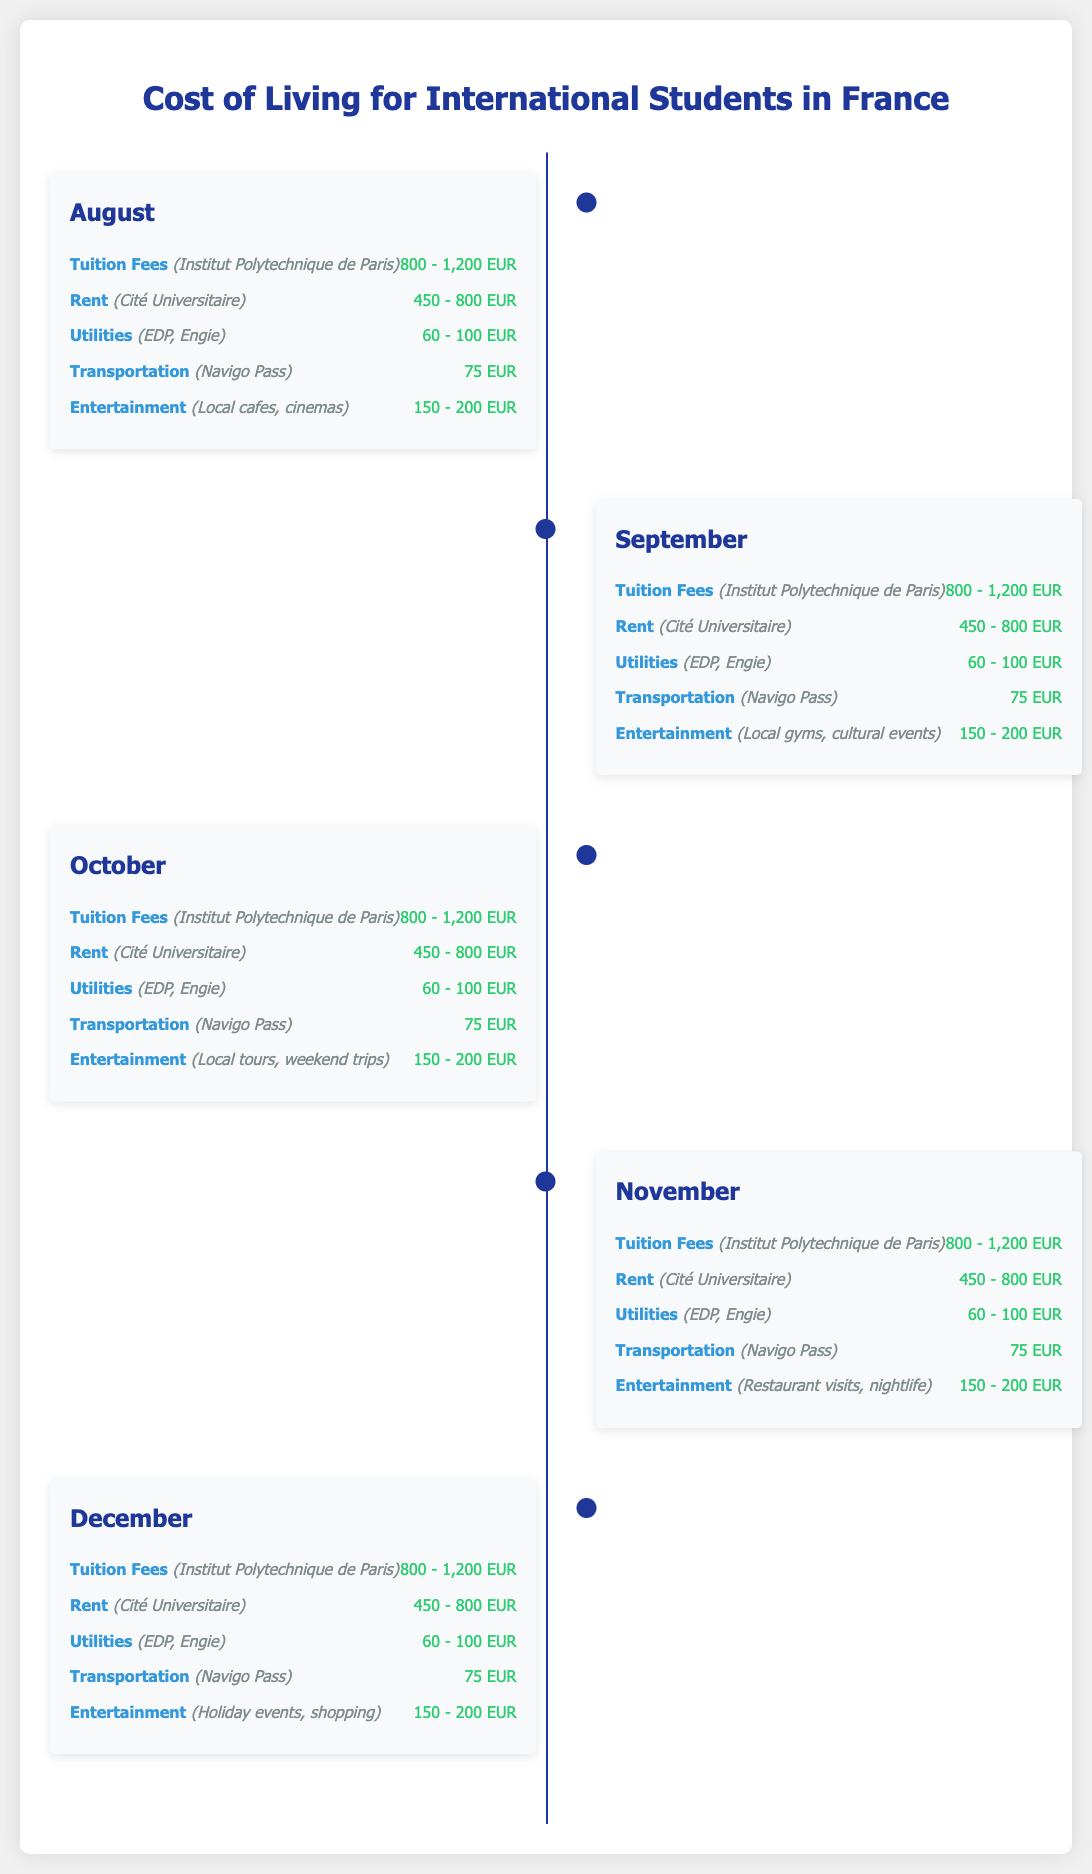What is the monthly rent range for August? The monthly rent range for August is specified in the "Rent" section under the month, which is 450 - 800 EUR.
Answer: 450 - 800 EUR How much is the transportation cost for September? The transportation cost for September is detailed in the "Transportation" section, which is 75 EUR.
Answer: 75 EUR What is the range of tuition fees for International Students? The tuition fees are listed as 800 - 1,200 EUR for each month from August to December.
Answer: 800 - 1,200 EUR Which month has entertainment costs for holiday events? The entertainment costs for holiday events are detailed for the month of December.
Answer: December What is the average utility bill range across all months? The average utility bill range is consistent at 60 - 100 EUR for all months, as stated in each monthly section.
Answer: 60 - 100 EUR Which month has the highest expected entertainment expenses indicated? While expenses are similar across months, all months mention entertainment expenses ranging from 150 - 200 EUR without variation in listed activities.
Answer: 150 - 200 EUR In what month are local cafes and cinemas mentioned for entertainment? Local cafes and cinemas are mentioned as entertainment for the month of August.
Answer: August What is the purpose of this document? The document provides a timeline infographic outlining the cost of living for international students in France, detailing monthly expenses.
Answer: Cost of living for international students in France 